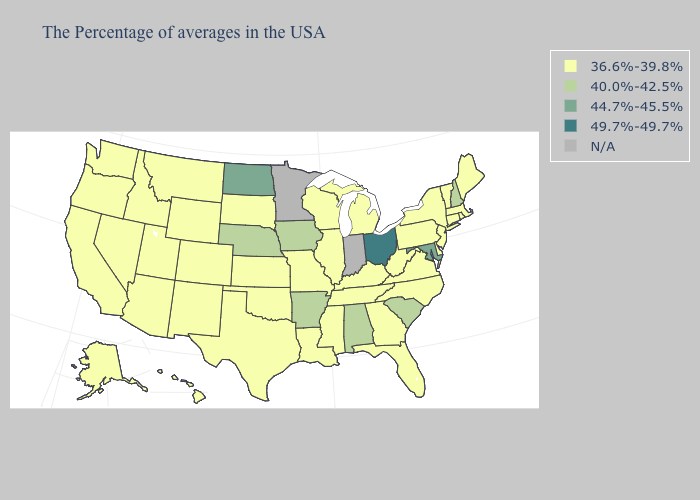What is the value of New Hampshire?
Keep it brief. 40.0%-42.5%. What is the lowest value in states that border Utah?
Short answer required. 36.6%-39.8%. What is the value of Wyoming?
Answer briefly. 36.6%-39.8%. Name the states that have a value in the range 44.7%-45.5%?
Short answer required. Maryland, North Dakota. Which states have the highest value in the USA?
Quick response, please. Ohio. What is the value of Nevada?
Concise answer only. 36.6%-39.8%. What is the highest value in states that border California?
Short answer required. 36.6%-39.8%. What is the highest value in the Northeast ?
Short answer required. 40.0%-42.5%. What is the value of North Carolina?
Quick response, please. 36.6%-39.8%. Among the states that border Iowa , does Nebraska have the highest value?
Quick response, please. Yes. What is the value of Colorado?
Quick response, please. 36.6%-39.8%. What is the value of Pennsylvania?
Quick response, please. 36.6%-39.8%. 